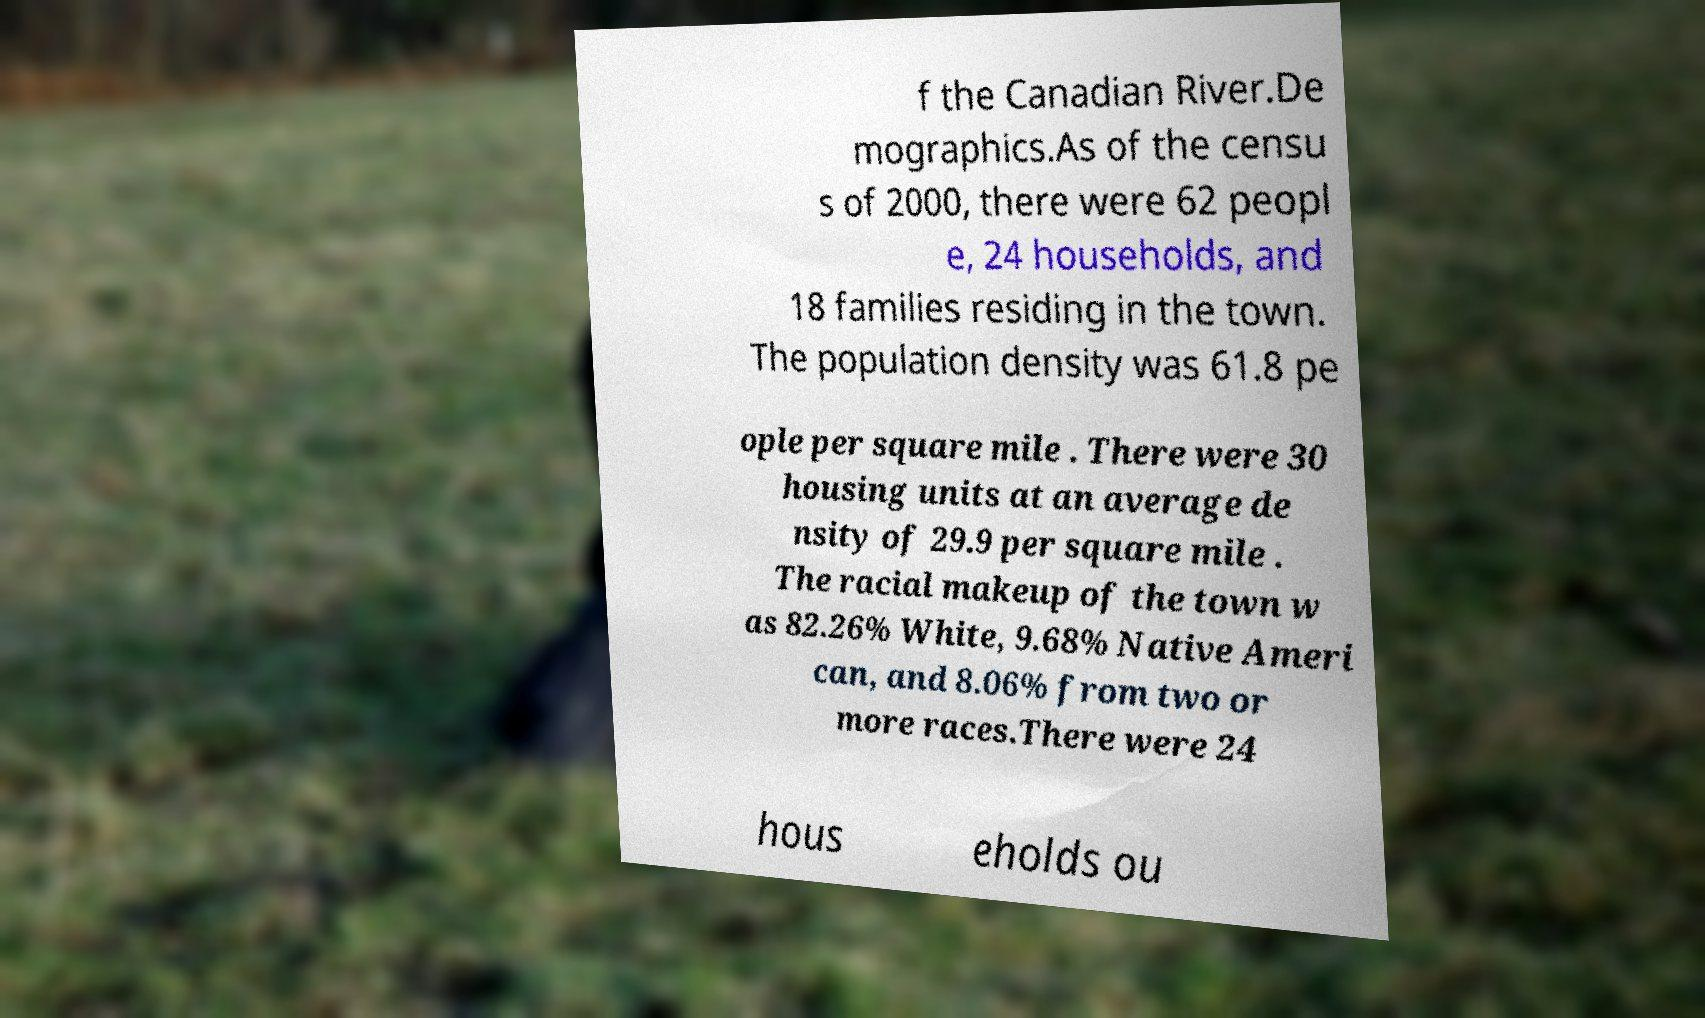Please identify and transcribe the text found in this image. f the Canadian River.De mographics.As of the censu s of 2000, there were 62 peopl e, 24 households, and 18 families residing in the town. The population density was 61.8 pe ople per square mile . There were 30 housing units at an average de nsity of 29.9 per square mile . The racial makeup of the town w as 82.26% White, 9.68% Native Ameri can, and 8.06% from two or more races.There were 24 hous eholds ou 